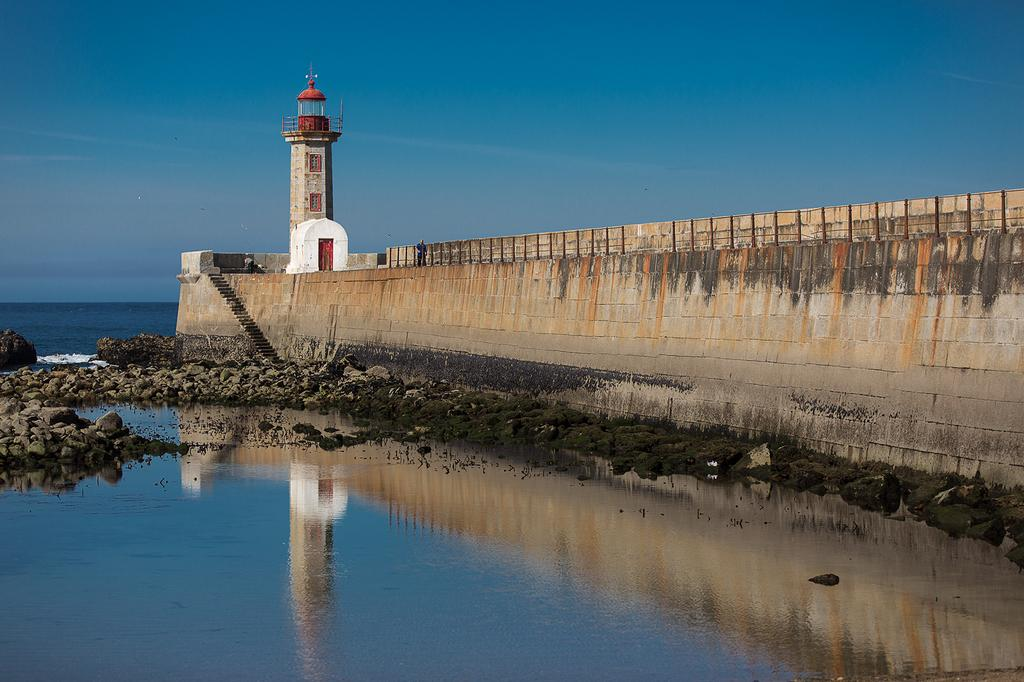What structure is the main subject of the image? There is a lighthouse in the image. What type of architectural feature can be seen in the image? There is a wall in the image. How can someone access the higher levels of the lighthouse? There are stairs in the image that provide access. What type of terrain is present in the image? Rocks are present in the image. What is visible in the background of the image? The sky is visible in the background of the image. What type of body of water is present in the image? There is water at the bottom of the image. What type of lumber is being used to construct the slope in the image? There is no slope or lumber present in the image. 